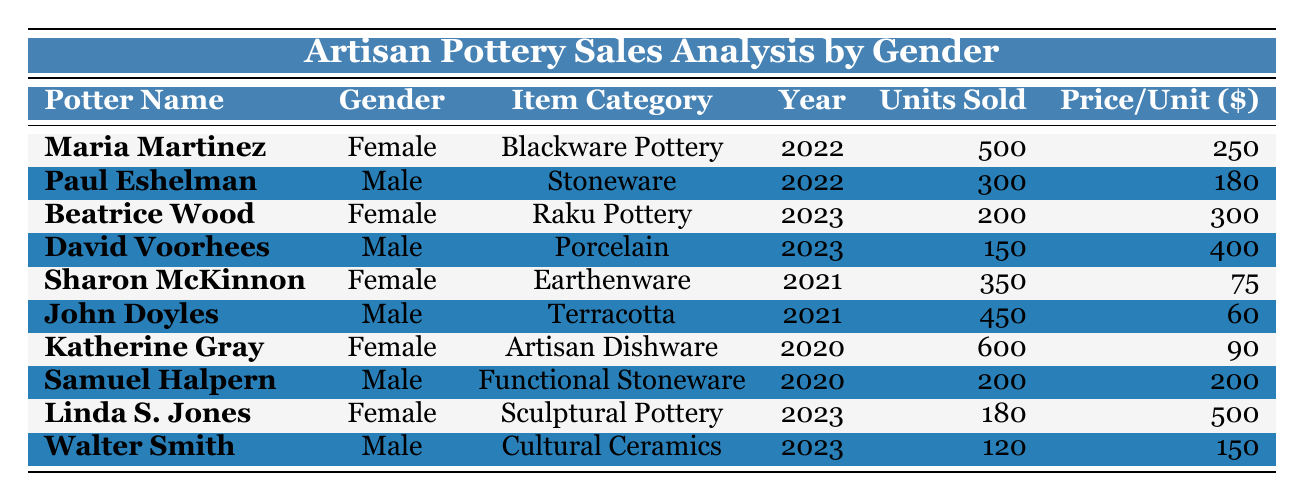What is the total number of units sold by female potters? By summing up the units sold for all female potters: 500 (Maria Martinez) + 200 (Beatrice Wood) + 350 (Sharon McKinnon) + 600 (Katherine Gray) + 180 (Linda S. Jones) = 1830 units.
Answer: 1830 What was the price per unit for the terracotta pottery sold by John Doyles? The price per unit for John Doyles, who sold terracotta pottery, is directly listed in the table as 60 dollars.
Answer: 60 In which year did Katherine Gray sell the most units? Katherine Gray's sales data shows she sold 600 units in 2020, making it the highest number of units sold compared to other years listed for her.
Answer: 2020 Who sold the least number of units and what item did they sell? The individual with the least units sold is Walter Smith, who sold 120 units of Cultural Ceramics.
Answer: Walter Smith, Cultural Ceramics What is the combined revenue generated by male potters in 2022? For male potters in 2022, Paul Eshelman sold 300 units at 180 dollars each, generating a revenue of 300 * 180 = 54,000 dollars. Thus the combined revenue is 54,000.
Answer: 54000 What percentage of total units sold were attributed to male potters? Total units sold by male potters are 300 (Paul Eshelman) + 450 (John Doyles) + 200 (Samuel Halpern) + 150 (David Voorhees) + 120 (Walter Smith) = 1220. The total units sold (1830 from females + 1220 from males) is 3050, so, percentage = (1220/3050) * 100 = 40%.
Answer: 40% Which item category had the highest selling price and what was it? Looking at the table, Sculptural Pottery by Linda S. Jones had the highest selling price at 500 dollars per unit.
Answer: Sculptural Pottery, 500 How much more did Maria Martinez earn from Blackware Pottery compared to the earnings of Beatrice Wood from Raku Pottery? Maria Martinez sold 500 units at 250 dollars each, earning 500 * 250 = 125,000 dollars. Beatrice Wood sold 200 units at 300 dollars each, earning 200 * 300 = 60,000 dollars. The difference is 125,000 - 60,000 = 65,000 dollars.
Answer: 65000 In which year did female potters collectively sell the most pottery? Calculating units sold by year: 2020 (600 + 0) = 600, 2021 (350 + 0) = 350, 2022 (500 + 0) = 500, and 2023 (200 + 180) = 380. Thus, 600 in 2020 is the highest.
Answer: 2020 